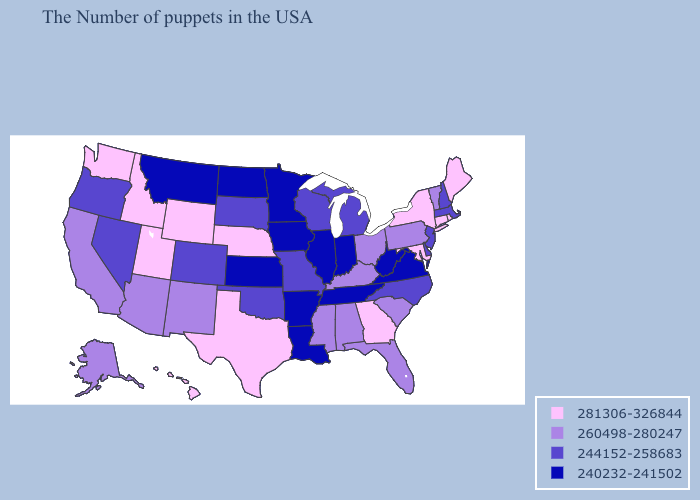Among the states that border Arkansas , which have the highest value?
Write a very short answer. Texas. Does Montana have a lower value than Arkansas?
Short answer required. No. Which states hav the highest value in the Northeast?
Concise answer only. Maine, Rhode Island, Connecticut, New York. What is the highest value in states that border New Jersey?
Give a very brief answer. 281306-326844. What is the lowest value in states that border Maine?
Short answer required. 244152-258683. What is the highest value in the Northeast ?
Write a very short answer. 281306-326844. What is the value of Massachusetts?
Quick response, please. 244152-258683. Name the states that have a value in the range 260498-280247?
Quick response, please. Vermont, Pennsylvania, South Carolina, Ohio, Florida, Kentucky, Alabama, Mississippi, New Mexico, Arizona, California, Alaska. Does South Dakota have the lowest value in the USA?
Keep it brief. No. Does New York have the same value as Texas?
Keep it brief. Yes. What is the highest value in the USA?
Answer briefly. 281306-326844. Among the states that border Washington , which have the lowest value?
Quick response, please. Oregon. Name the states that have a value in the range 240232-241502?
Give a very brief answer. Virginia, West Virginia, Indiana, Tennessee, Illinois, Louisiana, Arkansas, Minnesota, Iowa, Kansas, North Dakota, Montana. Does the map have missing data?
Quick response, please. No. Among the states that border Delaware , does Maryland have the lowest value?
Concise answer only. No. 